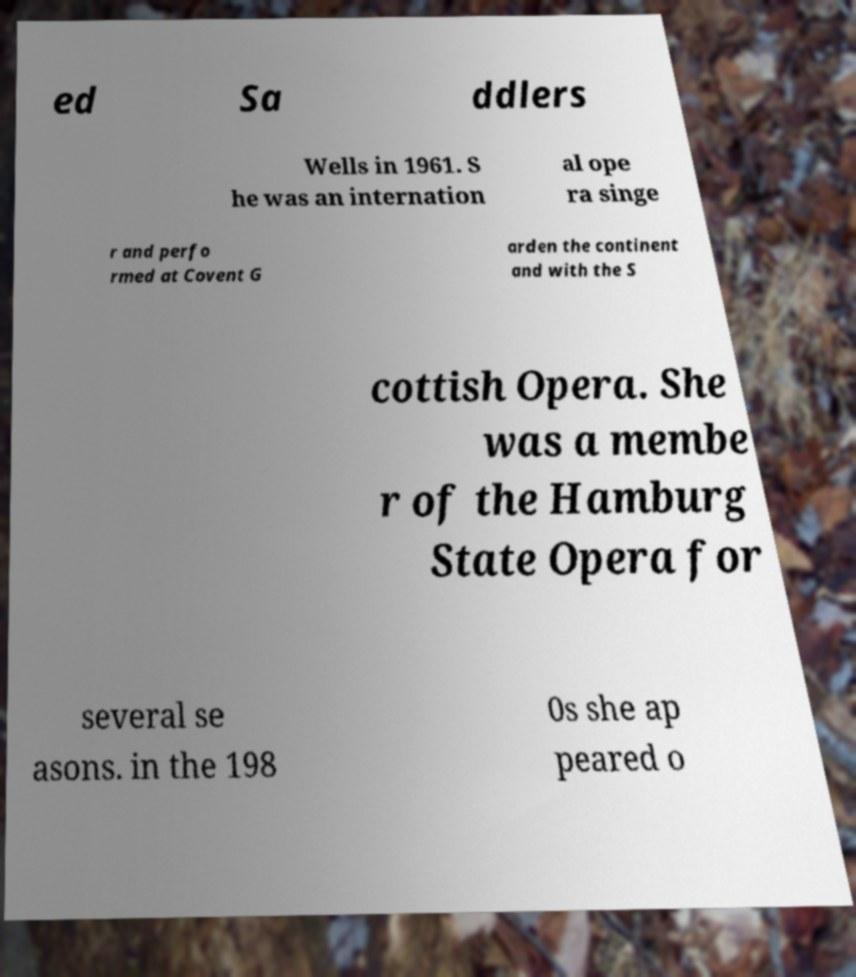What messages or text are displayed in this image? I need them in a readable, typed format. ed Sa ddlers Wells in 1961. S he was an internation al ope ra singe r and perfo rmed at Covent G arden the continent and with the S cottish Opera. She was a membe r of the Hamburg State Opera for several se asons. in the 198 0s she ap peared o 